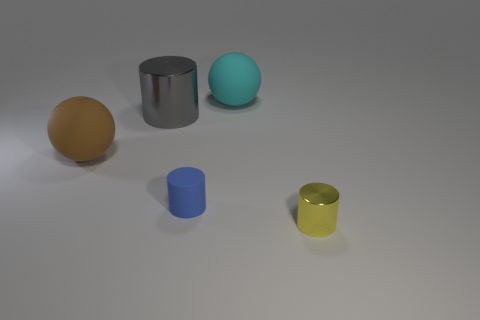Is there any other thing that is the same size as the blue cylinder?
Provide a short and direct response. Yes. The other matte thing that is the same shape as the big cyan rubber thing is what size?
Make the answer very short. Large. Is the number of large metallic cylinders on the right side of the cyan rubber ball greater than the number of tiny things that are in front of the gray shiny thing?
Make the answer very short. No. Are the tiny yellow cylinder and the sphere in front of the gray shiny thing made of the same material?
Your answer should be very brief. No. Are there any other things that are the same shape as the yellow object?
Offer a very short reply. Yes. The object that is both right of the blue cylinder and in front of the brown ball is what color?
Offer a terse response. Yellow. There is a shiny object in front of the gray cylinder; what shape is it?
Make the answer very short. Cylinder. What size is the metal cylinder left of the cylinder on the right side of the tiny cylinder left of the tiny yellow metallic cylinder?
Provide a short and direct response. Large. How many matte cylinders are on the left side of the large gray shiny cylinder behind the tiny yellow cylinder?
Your answer should be compact. 0. What is the size of the matte object that is both behind the blue rubber thing and in front of the large cyan sphere?
Make the answer very short. Large. 